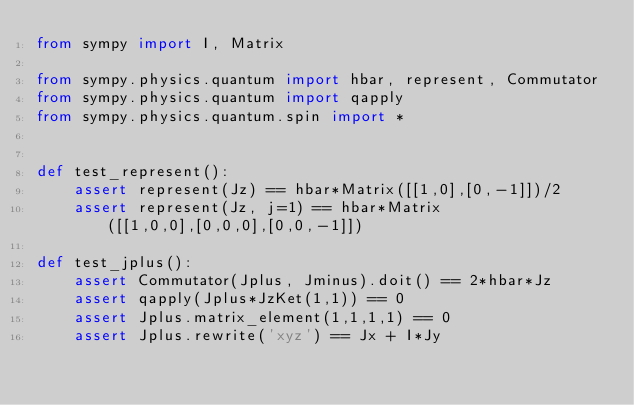<code> <loc_0><loc_0><loc_500><loc_500><_Python_>from sympy import I, Matrix

from sympy.physics.quantum import hbar, represent, Commutator
from sympy.physics.quantum import qapply
from sympy.physics.quantum.spin import *


def test_represent():
    assert represent(Jz) == hbar*Matrix([[1,0],[0,-1]])/2
    assert represent(Jz, j=1) == hbar*Matrix([[1,0,0],[0,0,0],[0,0,-1]])

def test_jplus():
    assert Commutator(Jplus, Jminus).doit() == 2*hbar*Jz
    assert qapply(Jplus*JzKet(1,1)) == 0
    assert Jplus.matrix_element(1,1,1,1) == 0
    assert Jplus.rewrite('xyz') == Jx + I*Jy
</code> 